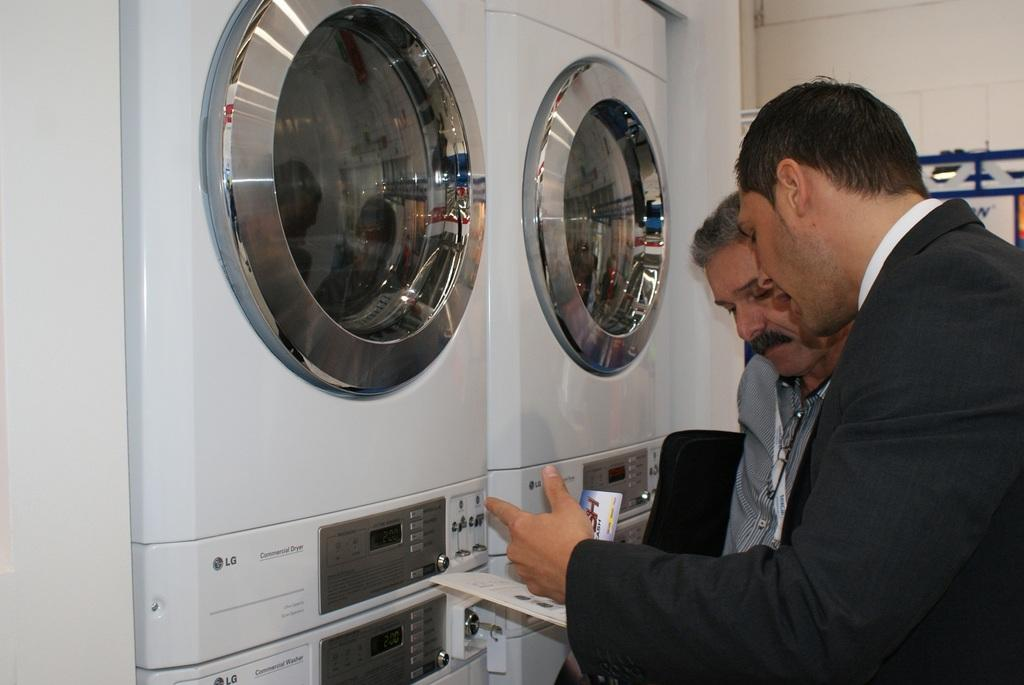How many men are visible on the right side of the image? There are two men on the right side of the image. What is the person holding in the image? A person in the image is holding a paper. What type of appliances can be seen on the left side of the image? There are washing machines on the left side of the image. What is visible in the background of the image? There is a wall in the background of the image. Can you see any wine bottles in the image? There is no wine bottle present in the image. Is there a crown visible on the head of one of the men in the image? There is no crown visible on the head of any person in the image. 